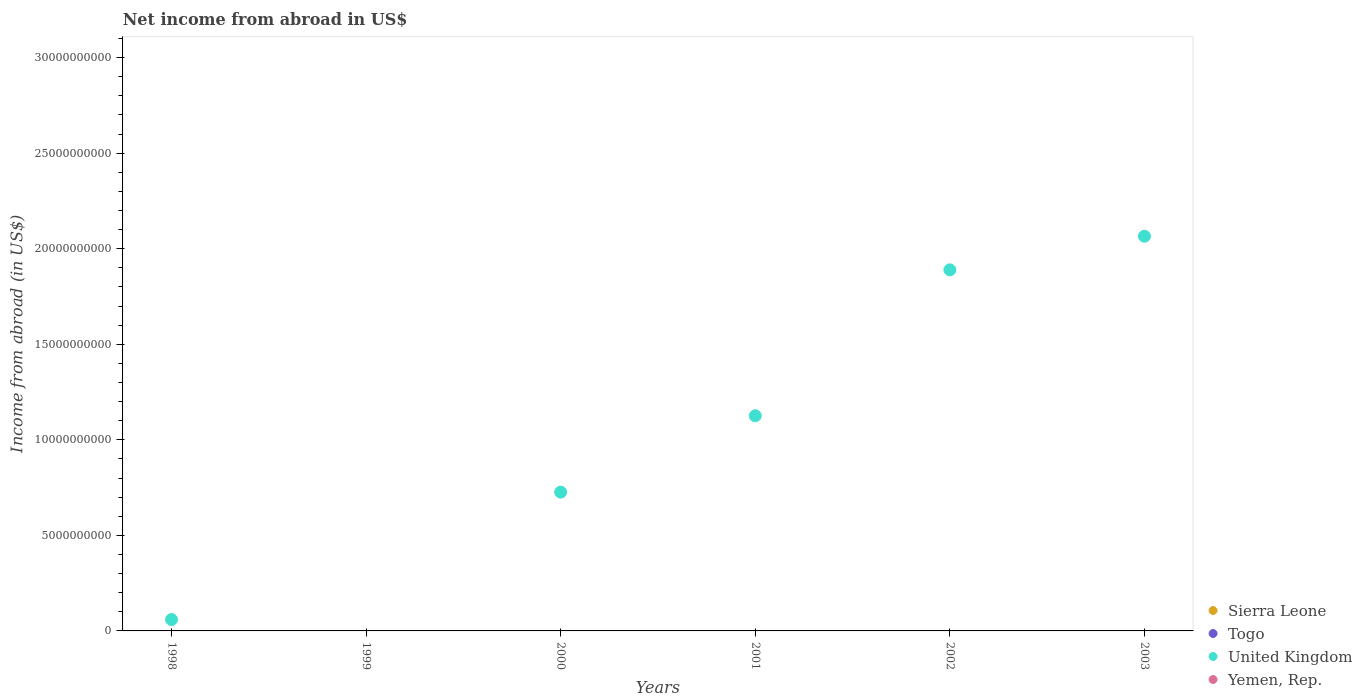How many different coloured dotlines are there?
Your answer should be compact. 1. Across all years, what is the maximum net income from abroad in United Kingdom?
Offer a terse response. 2.07e+1. Across all years, what is the minimum net income from abroad in Sierra Leone?
Your answer should be compact. 0. What is the total net income from abroad in Yemen, Rep. in the graph?
Keep it short and to the point. 0. What is the difference between the net income from abroad in United Kingdom in 2001 and that in 2003?
Offer a terse response. -9.40e+09. What is the difference between the net income from abroad in Sierra Leone in 2003 and the net income from abroad in United Kingdom in 2001?
Keep it short and to the point. -1.13e+1. In how many years, is the net income from abroad in United Kingdom greater than 20000000000 US$?
Your answer should be very brief. 1. What is the ratio of the net income from abroad in United Kingdom in 2001 to that in 2003?
Keep it short and to the point. 0.55. Is the net income from abroad in United Kingdom in 2001 less than that in 2003?
Give a very brief answer. Yes. What is the difference between the highest and the second highest net income from abroad in United Kingdom?
Provide a short and direct response. 1.76e+09. Is it the case that in every year, the sum of the net income from abroad in Yemen, Rep. and net income from abroad in Togo  is greater than the sum of net income from abroad in Sierra Leone and net income from abroad in United Kingdom?
Your answer should be compact. No. Is it the case that in every year, the sum of the net income from abroad in Togo and net income from abroad in Yemen, Rep.  is greater than the net income from abroad in United Kingdom?
Provide a succinct answer. No. Is the net income from abroad in Yemen, Rep. strictly less than the net income from abroad in Togo over the years?
Offer a terse response. Yes. Are the values on the major ticks of Y-axis written in scientific E-notation?
Make the answer very short. No. Does the graph contain any zero values?
Your answer should be compact. Yes. Where does the legend appear in the graph?
Provide a succinct answer. Bottom right. How many legend labels are there?
Provide a short and direct response. 4. What is the title of the graph?
Your response must be concise. Net income from abroad in US$. What is the label or title of the Y-axis?
Offer a very short reply. Income from abroad (in US$). What is the Income from abroad (in US$) of Togo in 1998?
Give a very brief answer. 0. What is the Income from abroad (in US$) of United Kingdom in 1998?
Ensure brevity in your answer.  5.96e+08. What is the Income from abroad (in US$) in Sierra Leone in 1999?
Keep it short and to the point. 0. What is the Income from abroad (in US$) of Togo in 1999?
Provide a short and direct response. 0. What is the Income from abroad (in US$) in Yemen, Rep. in 1999?
Provide a short and direct response. 0. What is the Income from abroad (in US$) in Sierra Leone in 2000?
Provide a short and direct response. 0. What is the Income from abroad (in US$) in Togo in 2000?
Your response must be concise. 0. What is the Income from abroad (in US$) in United Kingdom in 2000?
Your response must be concise. 7.26e+09. What is the Income from abroad (in US$) in Yemen, Rep. in 2000?
Give a very brief answer. 0. What is the Income from abroad (in US$) of Togo in 2001?
Provide a succinct answer. 0. What is the Income from abroad (in US$) in United Kingdom in 2001?
Your response must be concise. 1.13e+1. What is the Income from abroad (in US$) of Sierra Leone in 2002?
Your answer should be compact. 0. What is the Income from abroad (in US$) in Togo in 2002?
Offer a terse response. 0. What is the Income from abroad (in US$) of United Kingdom in 2002?
Your response must be concise. 1.89e+1. What is the Income from abroad (in US$) in Yemen, Rep. in 2002?
Provide a short and direct response. 0. What is the Income from abroad (in US$) of Togo in 2003?
Your answer should be compact. 0. What is the Income from abroad (in US$) of United Kingdom in 2003?
Your answer should be very brief. 2.07e+1. Across all years, what is the maximum Income from abroad (in US$) in United Kingdom?
Keep it short and to the point. 2.07e+1. What is the total Income from abroad (in US$) in Togo in the graph?
Your response must be concise. 0. What is the total Income from abroad (in US$) of United Kingdom in the graph?
Offer a terse response. 5.87e+1. What is the difference between the Income from abroad (in US$) in United Kingdom in 1998 and that in 2000?
Give a very brief answer. -6.67e+09. What is the difference between the Income from abroad (in US$) in United Kingdom in 1998 and that in 2001?
Your answer should be very brief. -1.07e+1. What is the difference between the Income from abroad (in US$) in United Kingdom in 1998 and that in 2002?
Ensure brevity in your answer.  -1.83e+1. What is the difference between the Income from abroad (in US$) of United Kingdom in 1998 and that in 2003?
Ensure brevity in your answer.  -2.01e+1. What is the difference between the Income from abroad (in US$) of United Kingdom in 2000 and that in 2001?
Keep it short and to the point. -4.00e+09. What is the difference between the Income from abroad (in US$) of United Kingdom in 2000 and that in 2002?
Provide a short and direct response. -1.16e+1. What is the difference between the Income from abroad (in US$) in United Kingdom in 2000 and that in 2003?
Ensure brevity in your answer.  -1.34e+1. What is the difference between the Income from abroad (in US$) of United Kingdom in 2001 and that in 2002?
Offer a very short reply. -7.64e+09. What is the difference between the Income from abroad (in US$) in United Kingdom in 2001 and that in 2003?
Your response must be concise. -9.40e+09. What is the difference between the Income from abroad (in US$) in United Kingdom in 2002 and that in 2003?
Keep it short and to the point. -1.76e+09. What is the average Income from abroad (in US$) in United Kingdom per year?
Provide a short and direct response. 9.78e+09. What is the ratio of the Income from abroad (in US$) in United Kingdom in 1998 to that in 2000?
Offer a very short reply. 0.08. What is the ratio of the Income from abroad (in US$) of United Kingdom in 1998 to that in 2001?
Provide a short and direct response. 0.05. What is the ratio of the Income from abroad (in US$) of United Kingdom in 1998 to that in 2002?
Offer a very short reply. 0.03. What is the ratio of the Income from abroad (in US$) of United Kingdom in 1998 to that in 2003?
Make the answer very short. 0.03. What is the ratio of the Income from abroad (in US$) in United Kingdom in 2000 to that in 2001?
Your response must be concise. 0.65. What is the ratio of the Income from abroad (in US$) of United Kingdom in 2000 to that in 2002?
Give a very brief answer. 0.38. What is the ratio of the Income from abroad (in US$) of United Kingdom in 2000 to that in 2003?
Provide a short and direct response. 0.35. What is the ratio of the Income from abroad (in US$) in United Kingdom in 2001 to that in 2002?
Ensure brevity in your answer.  0.6. What is the ratio of the Income from abroad (in US$) of United Kingdom in 2001 to that in 2003?
Offer a very short reply. 0.55. What is the ratio of the Income from abroad (in US$) in United Kingdom in 2002 to that in 2003?
Your answer should be very brief. 0.91. What is the difference between the highest and the second highest Income from abroad (in US$) of United Kingdom?
Your answer should be very brief. 1.76e+09. What is the difference between the highest and the lowest Income from abroad (in US$) of United Kingdom?
Your answer should be compact. 2.07e+1. 